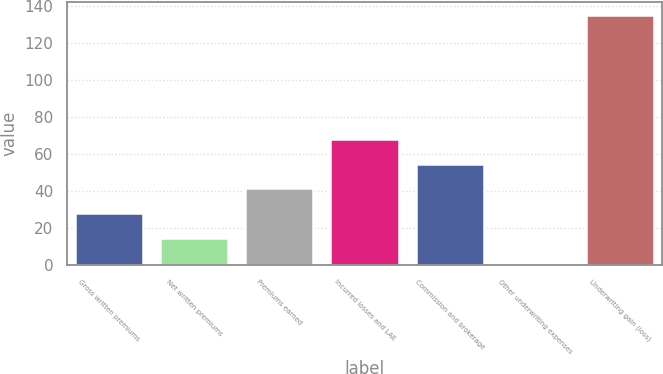Convert chart. <chart><loc_0><loc_0><loc_500><loc_500><bar_chart><fcel>Gross written premiums<fcel>Net written premiums<fcel>Premiums earned<fcel>Incurred losses and LAE<fcel>Commission and brokerage<fcel>Other underwriting expenses<fcel>Underwriting gain (loss)<nl><fcel>28.04<fcel>14.62<fcel>41.46<fcel>68.3<fcel>54.88<fcel>1.2<fcel>135.4<nl></chart> 